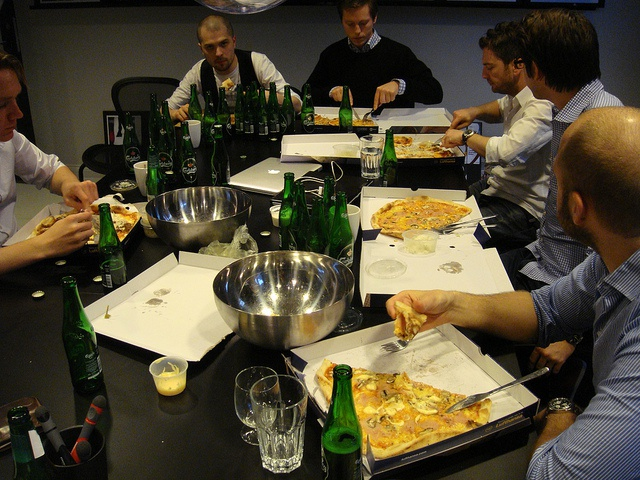Describe the objects in this image and their specific colors. I can see dining table in black, beige, tan, and olive tones, people in black, gray, maroon, and olive tones, people in black, gray, maroon, and tan tones, people in black, gray, maroon, and darkgray tones, and bowl in black, olive, tan, and gray tones in this image. 